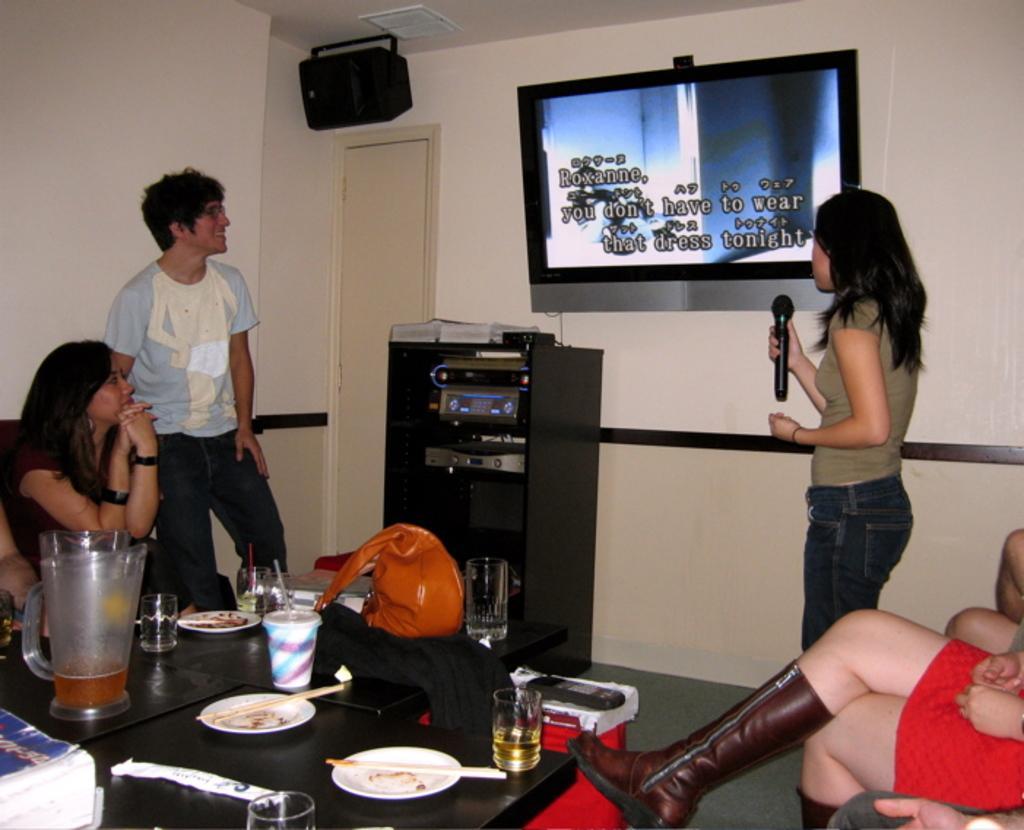Can you describe this image briefly? In this image I can see few people where few are standing and rest are sitting. Here I can see she is holding a mic and a smile on his face. On this table I can see a bag, few plates, few glasses, a phone and a jar. In the background I can see a screen and a speaker. 